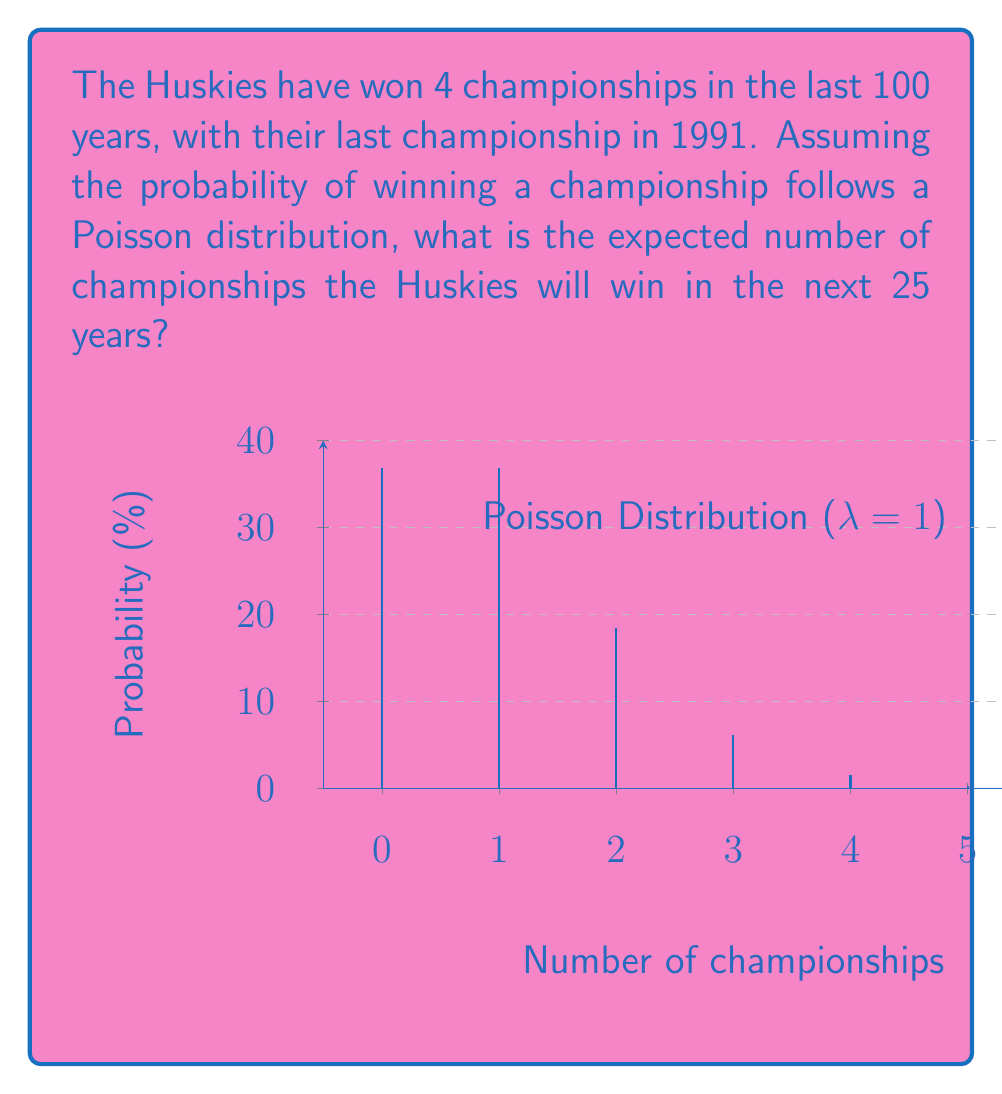Can you answer this question? Let's approach this step-by-step:

1) First, we need to calculate the rate parameter $\lambda$ for the Poisson distribution. This is the average number of events (championships) per time period.

   $\lambda = \frac{\text{Number of championships}}{\text{Number of years}} = \frac{4}{100} = 0.04$ championships per year

2) We want to find the expected number of championships for the next 25 years. The Poisson parameter for this period would be:

   $\lambda_{25} = 0.04 \times 25 = 1$

3) For a Poisson distribution, the expected value is equal to the rate parameter $\lambda$. Therefore, the expected number of championships in the next 25 years is:

   $E(X) = \lambda_{25} = 1$

4) This means that, on average, we would expect the Huskies to win 1 championship in the next 25 years based on their past performance.

Note: The graph in the question illustrates a Poisson distribution with $\lambda = 1$, which matches our calculated value for the next 25 years.
Answer: 1 championship 